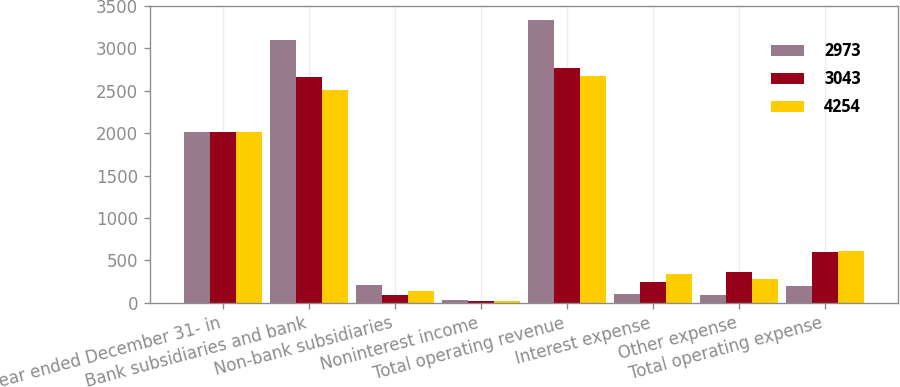Convert chart. <chart><loc_0><loc_0><loc_500><loc_500><stacked_bar_chart><ecel><fcel>Year ended December 31- in<fcel>Bank subsidiaries and bank<fcel>Non-bank subsidiaries<fcel>Noninterest income<fcel>Total operating revenue<fcel>Interest expense<fcel>Other expense<fcel>Total operating expense<nl><fcel>2973<fcel>2013<fcel>3105<fcel>205<fcel>28<fcel>3338<fcel>107<fcel>93<fcel>200<nl><fcel>3043<fcel>2012<fcel>2660<fcel>91<fcel>22<fcel>2773<fcel>242<fcel>359<fcel>601<nl><fcel>4254<fcel>2011<fcel>2513<fcel>131<fcel>24<fcel>2669<fcel>333<fcel>275<fcel>608<nl></chart> 